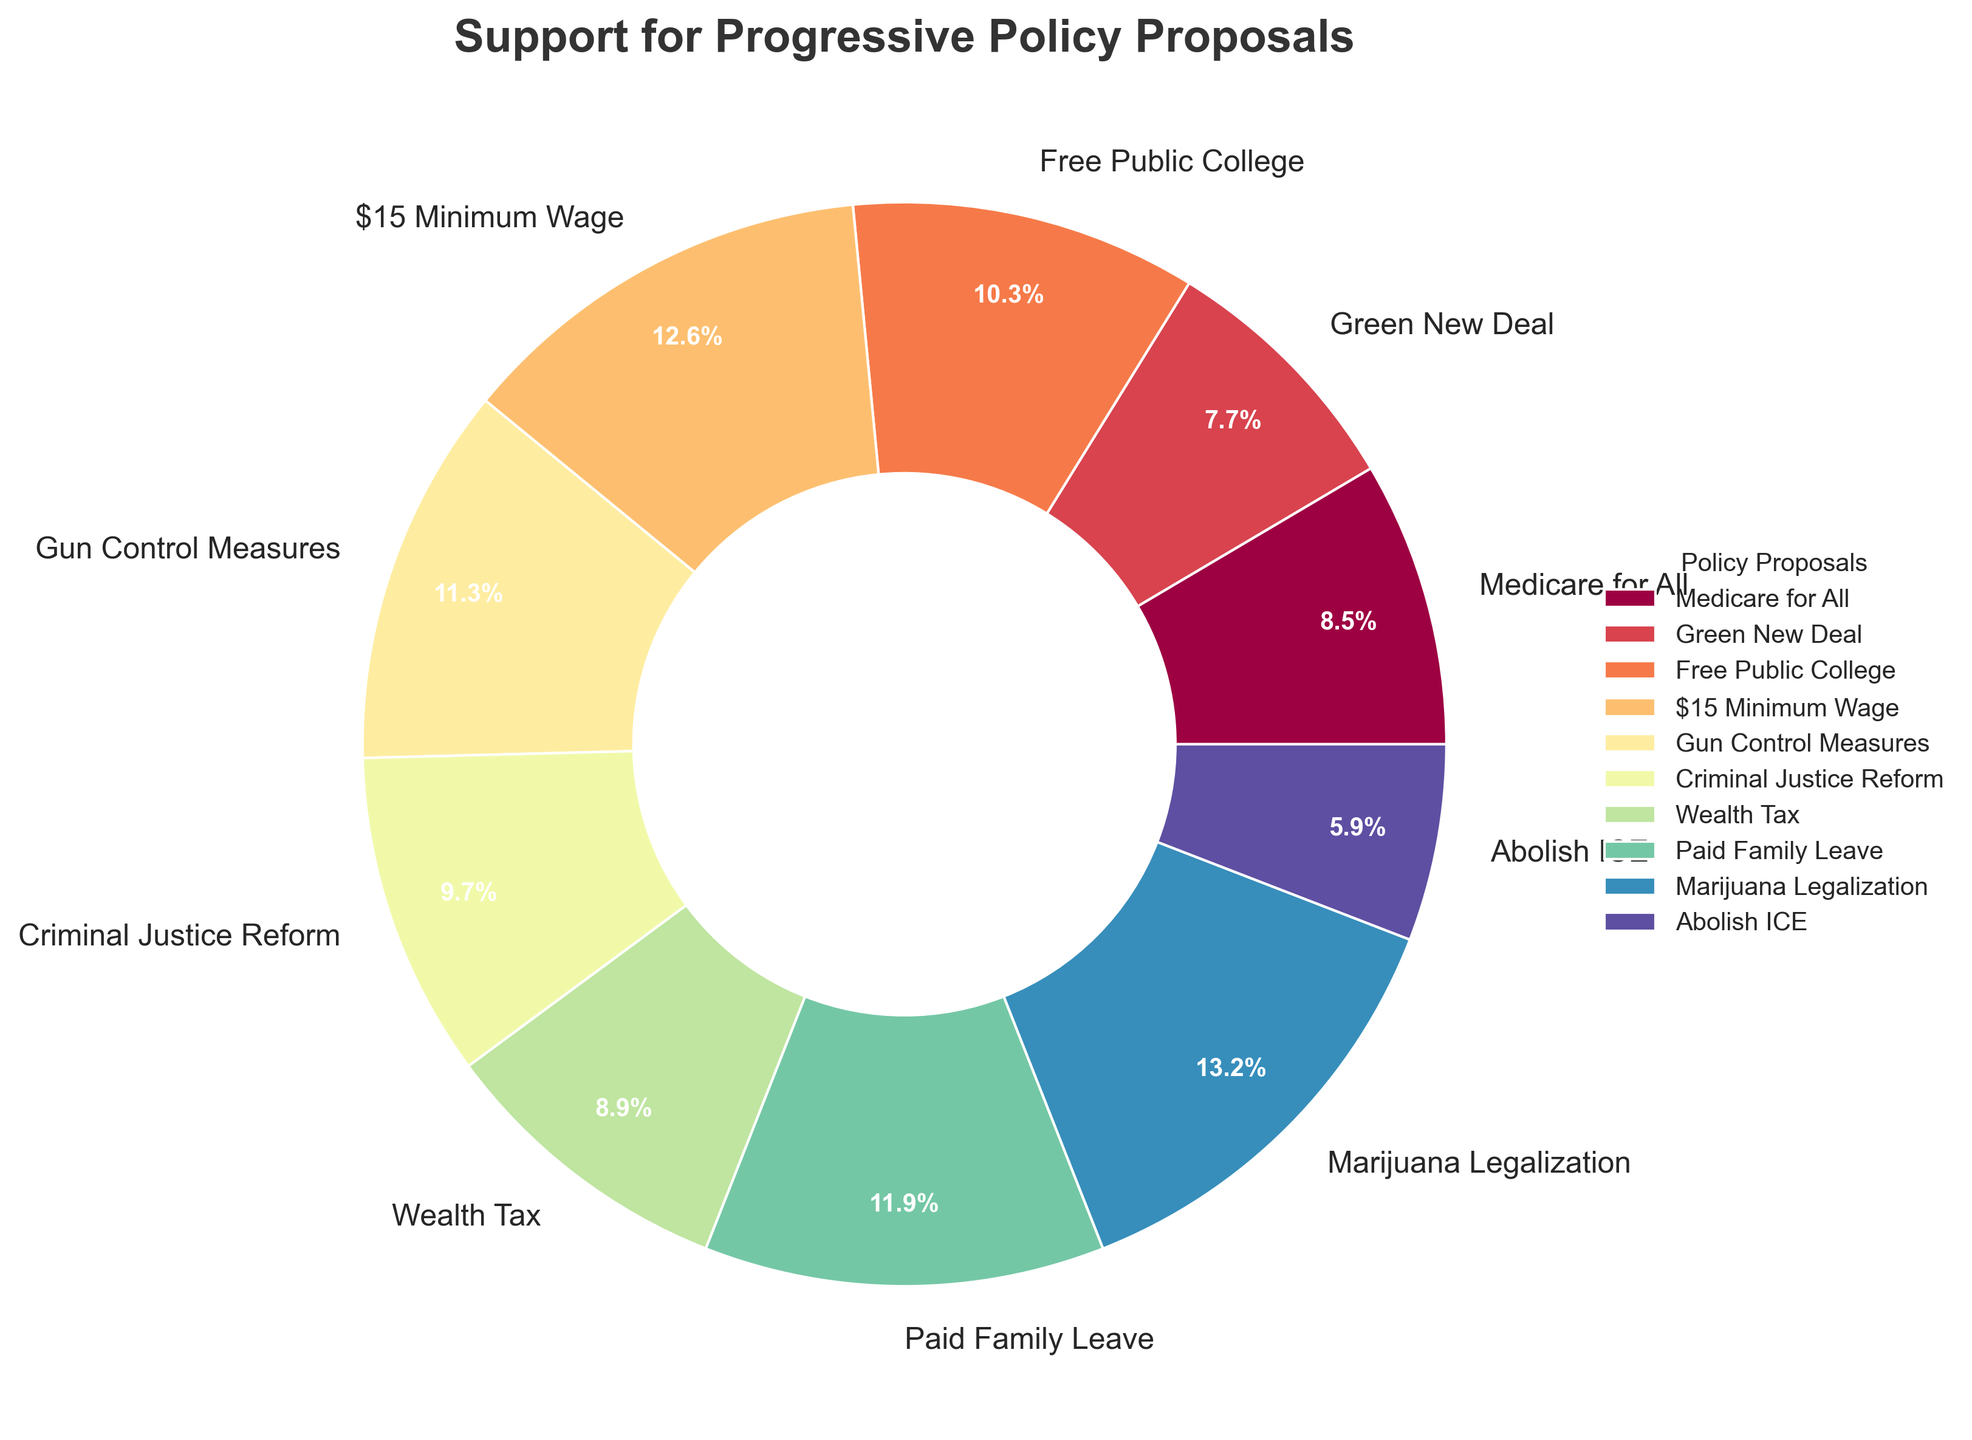Which policy proposal has the highest support percentage? The figure lists all policy proposals along with their support percentages. To determine which has the highest support, look for the one with the highest value percentage. Marijuana Legalization has a support percentage of 65%, the highest among the listed policies.
Answer: Marijuana Legalization Which policy proposal has the lowest support percentage? Similarly, to find the policy with the lowest support, identify the one with the smallest percentage value. In the figure, Abolish ICE has the lowest support percentage at 29%.
Answer: Abolish ICE What is the difference in support percentage between Medicare for All and Green New Deal? To find the difference in support, subtract the smaller percentage from the larger one. For Medicare for All (42%) and Green New Deal (38%), the difference is 42 - 38 = 4.
Answer: 4 How many policy proposals have a support percentage above 50%? Count the number of policies with support percentages greater than 50%. In this case, the policies are: Free Public College (51%), $15 Minimum Wage (62%), Gun Control Measures (56%), Paid Family Leave (59%), and Marijuana Legalization (65%). So, there are 5 policies.
Answer: 5 Which policy proposals have a support percentage between 40% and 50% inclusive? Identify the policies with percentages within the 40% to 50% range. The figure lists Medicare for All (42%), Green New Deal (38%), Criminal Justice Reform (48%), and Wealth Tax (44%). Only Medicare for All, Criminal Justice Reform, and Wealth Tax fall in the specified range.
Answer: Medicare for All, Criminal Justice Reform, Wealth Tax What is the average support percentage of the policies listed? To find the average, sum all the percentages and then divide by the number of policies. The percentages are 42, 38, 51, 62, 56, 48, 44, 59, 65, 29. Summing these gives 494. There are 10 policies, so the average is 494 / 10 = 49.4.
Answer: 49.4 Is Gun Control Measures more popular than Wealth Tax? Compare the support percentages of Gun Control Measures and Wealth Tax. Gun Control Measures has a support percentage of 56%, while Wealth Tax has 44%. Since 56 > 44, Gun Control Measures is more popular.
Answer: Yes What is the combined support percentage for Green New Deal and Criminal Justice Reform? Add the support percentages of Green New Deal (38%) and Criminal Justice Reform (48%) to find the combined support: 38 + 48 = 86.
Answer: 86 Are more than half of the policies supported by at least 50% of voters? Count how many policies have 50% or more support. Policies above 50% are Free Public College (51%), $15 Minimum Wage (62%), Gun Control Measures (56%), Paid Family Leave (59%), and Marijuana Legalization (65%). There are 5 policies with 50% or more support out of 10; half of 10 is 5, so exactly half, not more than half, are above 50%.
Answer: No 